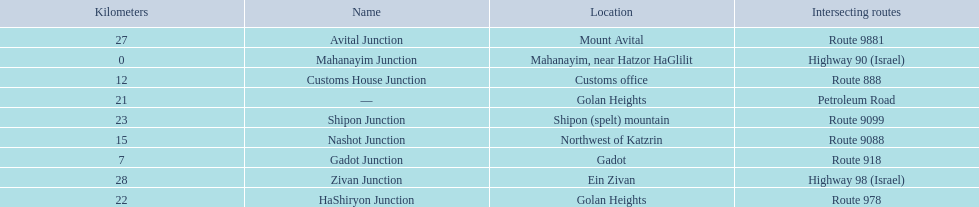Which intersecting routes are route 918 Route 918. What is the name? Gadot Junction. 